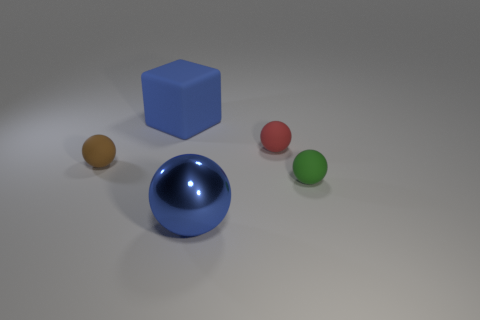Does the sphere that is on the left side of the large blue block have the same material as the blue cube? yes 